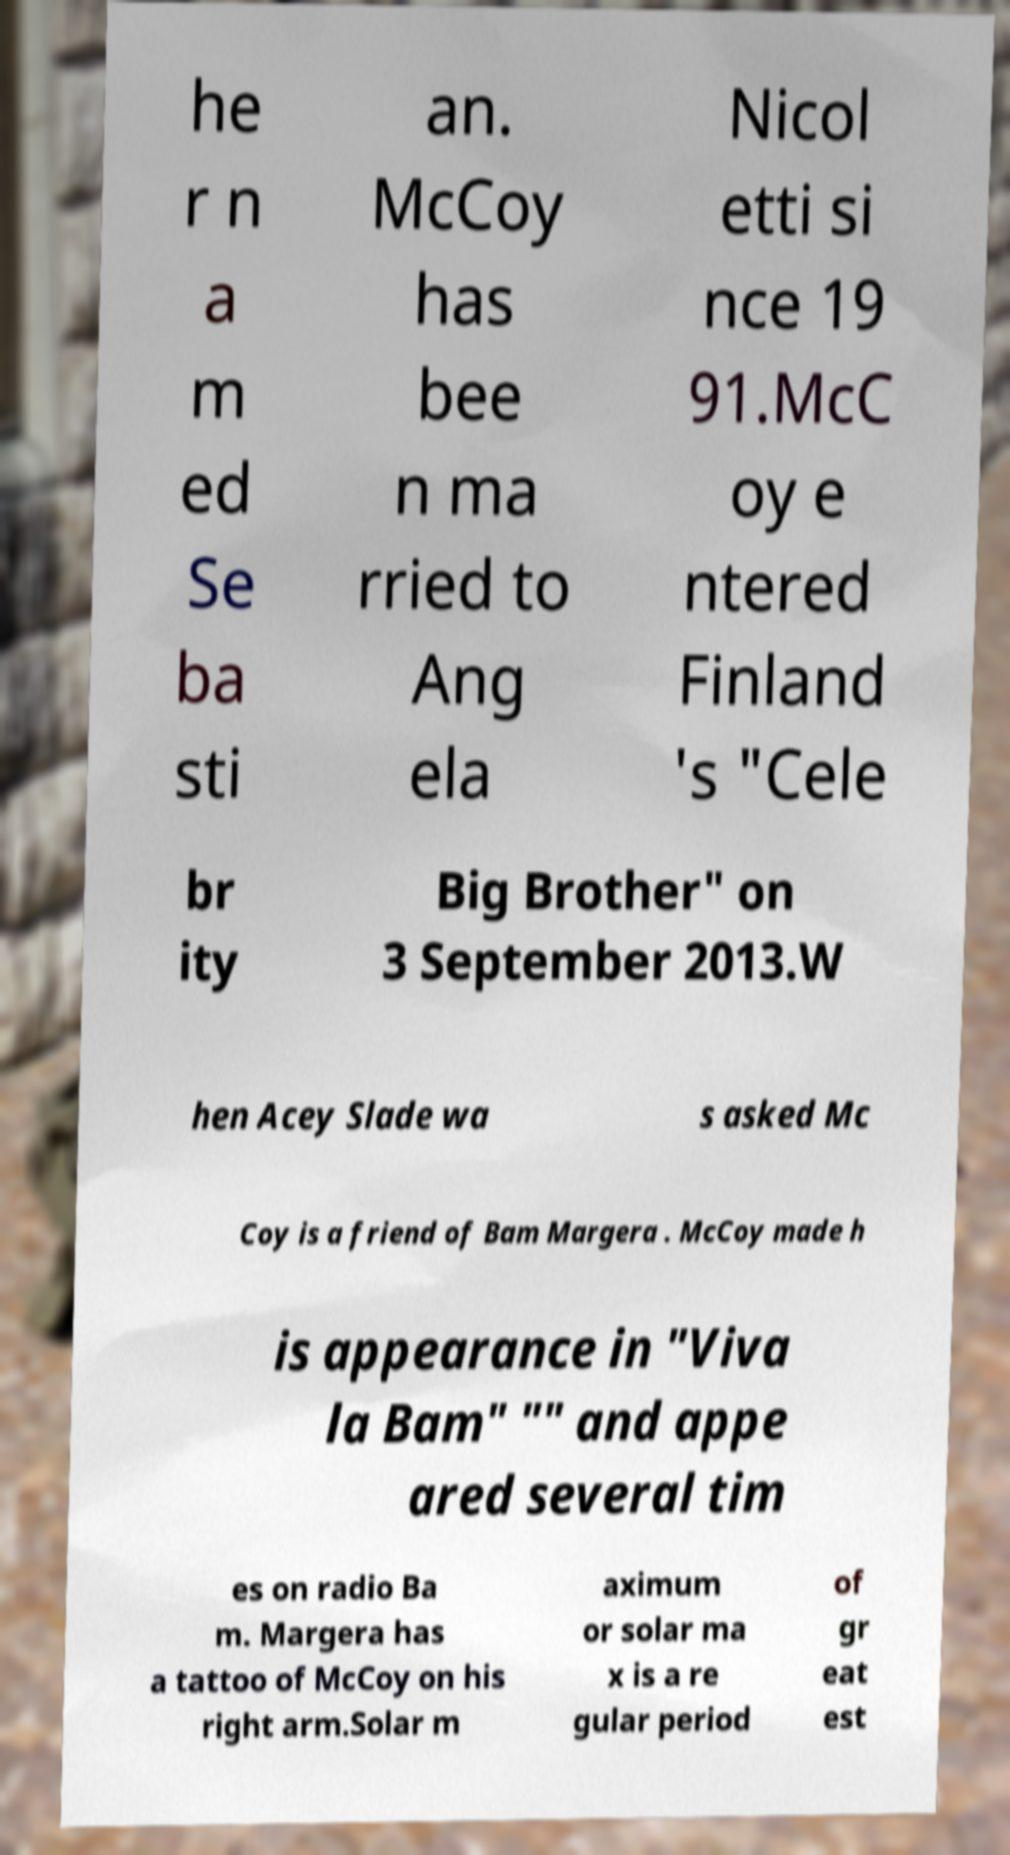Could you assist in decoding the text presented in this image and type it out clearly? he r n a m ed Se ba sti an. McCoy has bee n ma rried to Ang ela Nicol etti si nce 19 91.McC oy e ntered Finland 's "Cele br ity Big Brother" on 3 September 2013.W hen Acey Slade wa s asked Mc Coy is a friend of Bam Margera . McCoy made h is appearance in "Viva la Bam" "" and appe ared several tim es on radio Ba m. Margera has a tattoo of McCoy on his right arm.Solar m aximum or solar ma x is a re gular period of gr eat est 